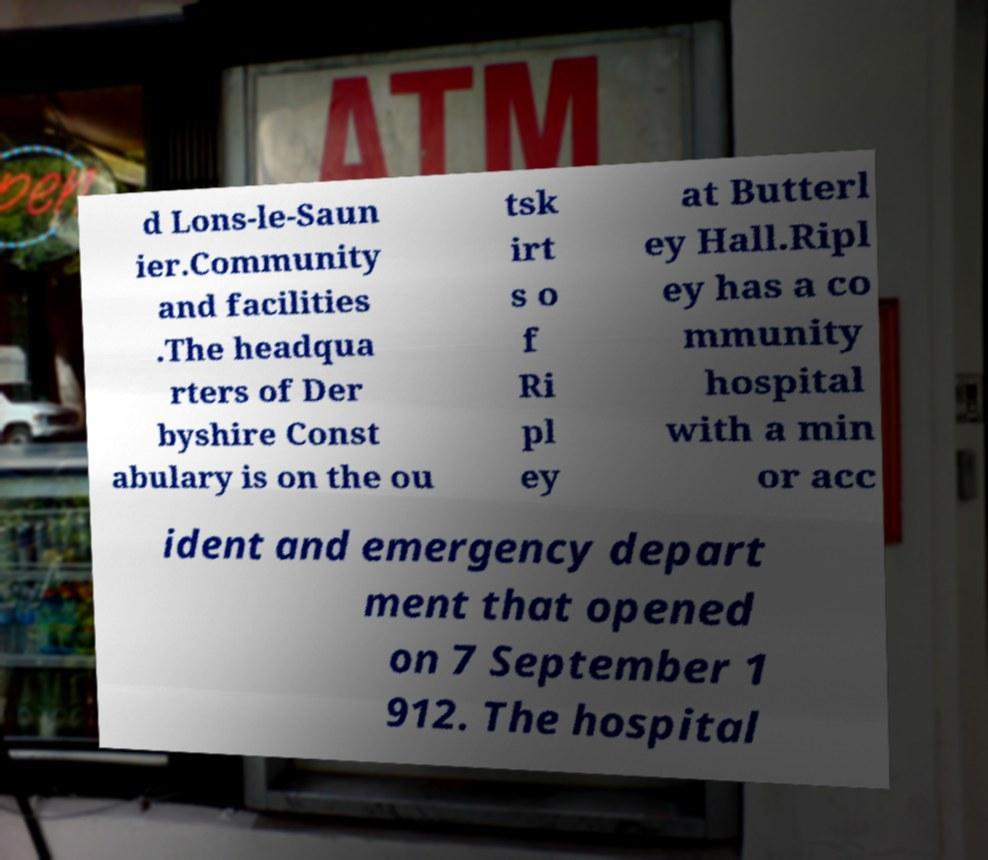I need the written content from this picture converted into text. Can you do that? d Lons-le-Saun ier.Community and facilities .The headqua rters of Der byshire Const abulary is on the ou tsk irt s o f Ri pl ey at Butterl ey Hall.Ripl ey has a co mmunity hospital with a min or acc ident and emergency depart ment that opened on 7 September 1 912. The hospital 